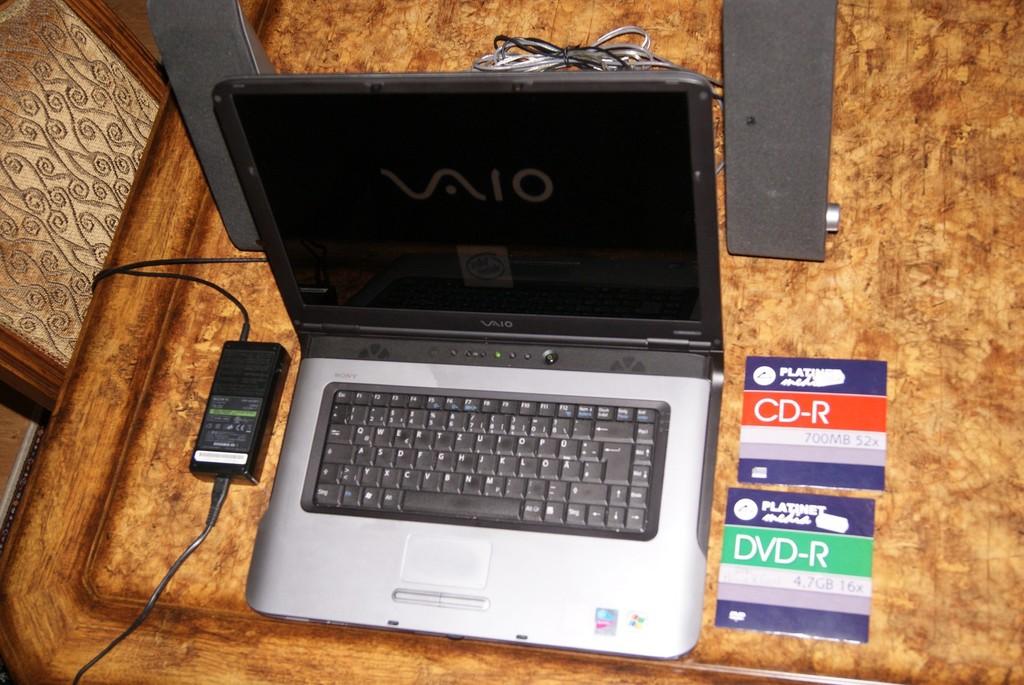What brand of laptop is this?
Offer a very short reply. Vaio. What type of disc is on the case with a red label?
Ensure brevity in your answer.  Cd-r. 